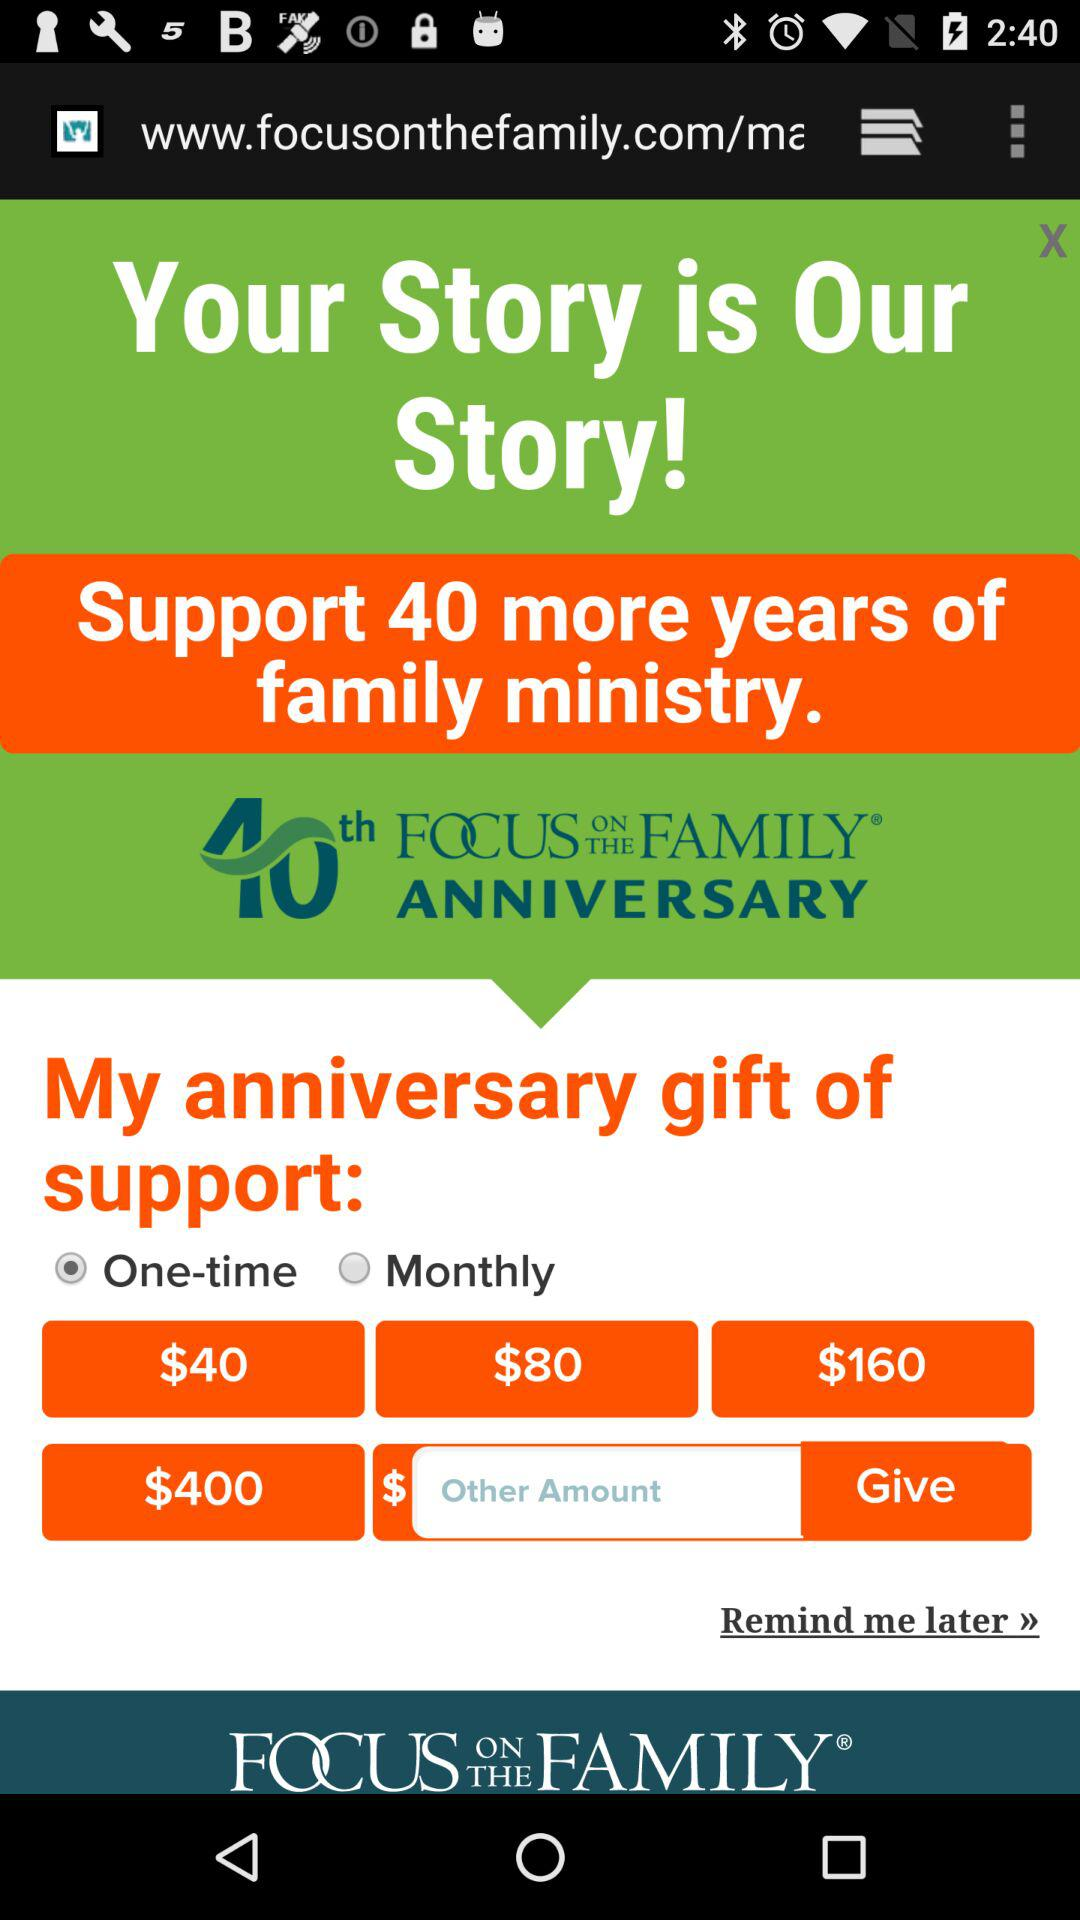Which anniversary of "Focus on the Family" is it? It is the 40th anniversary. 